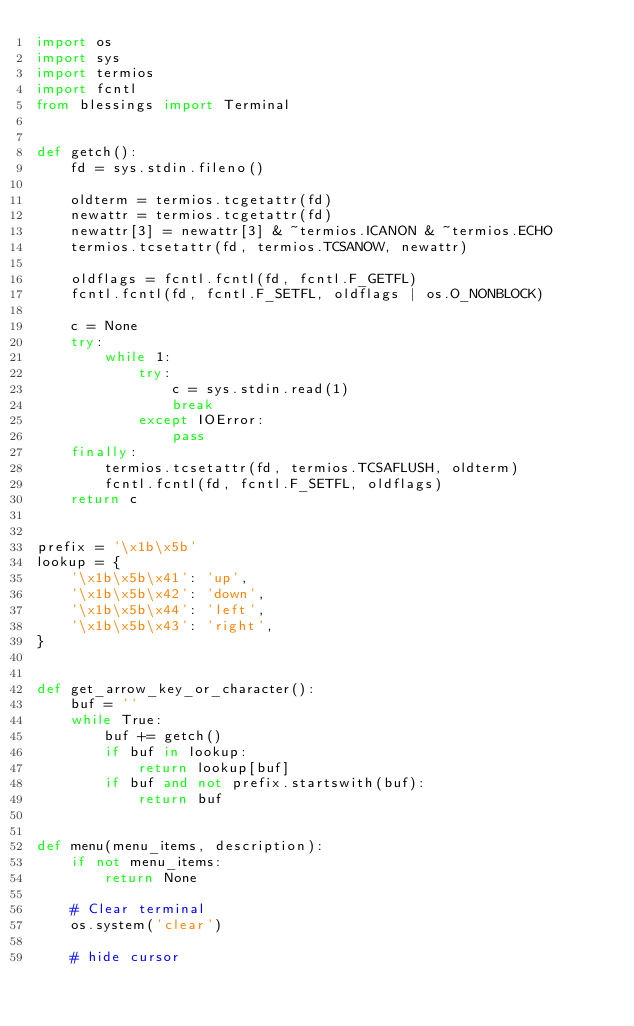Convert code to text. <code><loc_0><loc_0><loc_500><loc_500><_Python_>import os
import sys
import termios
import fcntl
from blessings import Terminal


def getch():
    fd = sys.stdin.fileno()

    oldterm = termios.tcgetattr(fd)
    newattr = termios.tcgetattr(fd)
    newattr[3] = newattr[3] & ~termios.ICANON & ~termios.ECHO
    termios.tcsetattr(fd, termios.TCSANOW, newattr)

    oldflags = fcntl.fcntl(fd, fcntl.F_GETFL)
    fcntl.fcntl(fd, fcntl.F_SETFL, oldflags | os.O_NONBLOCK)

    c = None
    try:
        while 1:
            try:
                c = sys.stdin.read(1)
                break
            except IOError:
                pass
    finally:
        termios.tcsetattr(fd, termios.TCSAFLUSH, oldterm)
        fcntl.fcntl(fd, fcntl.F_SETFL, oldflags)
    return c


prefix = '\x1b\x5b'
lookup = {
    '\x1b\x5b\x41': 'up',
    '\x1b\x5b\x42': 'down',
    '\x1b\x5b\x44': 'left',
    '\x1b\x5b\x43': 'right',
}


def get_arrow_key_or_character():
    buf = ''
    while True:
        buf += getch()
        if buf in lookup:
            return lookup[buf]
        if buf and not prefix.startswith(buf):
            return buf


def menu(menu_items, description):
    if not menu_items:
        return None

    # Clear terminal
    os.system('clear')

    # hide cursor</code> 